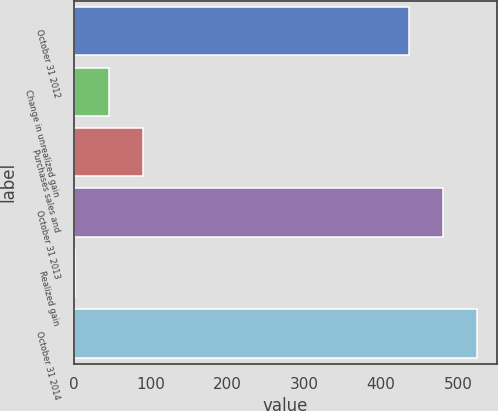Convert chart. <chart><loc_0><loc_0><loc_500><loc_500><bar_chart><fcel>October 31 2012<fcel>Change in unrealized gain<fcel>Purchases sales and<fcel>October 31 2013<fcel>Realized gain<fcel>October 31 2014<nl><fcel>436<fcel>45.5<fcel>90<fcel>480.5<fcel>1<fcel>525<nl></chart> 